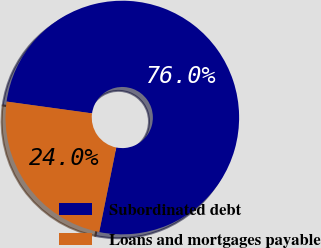Convert chart. <chart><loc_0><loc_0><loc_500><loc_500><pie_chart><fcel>Subordinated debt<fcel>Loans and mortgages payable<nl><fcel>75.99%<fcel>24.01%<nl></chart> 